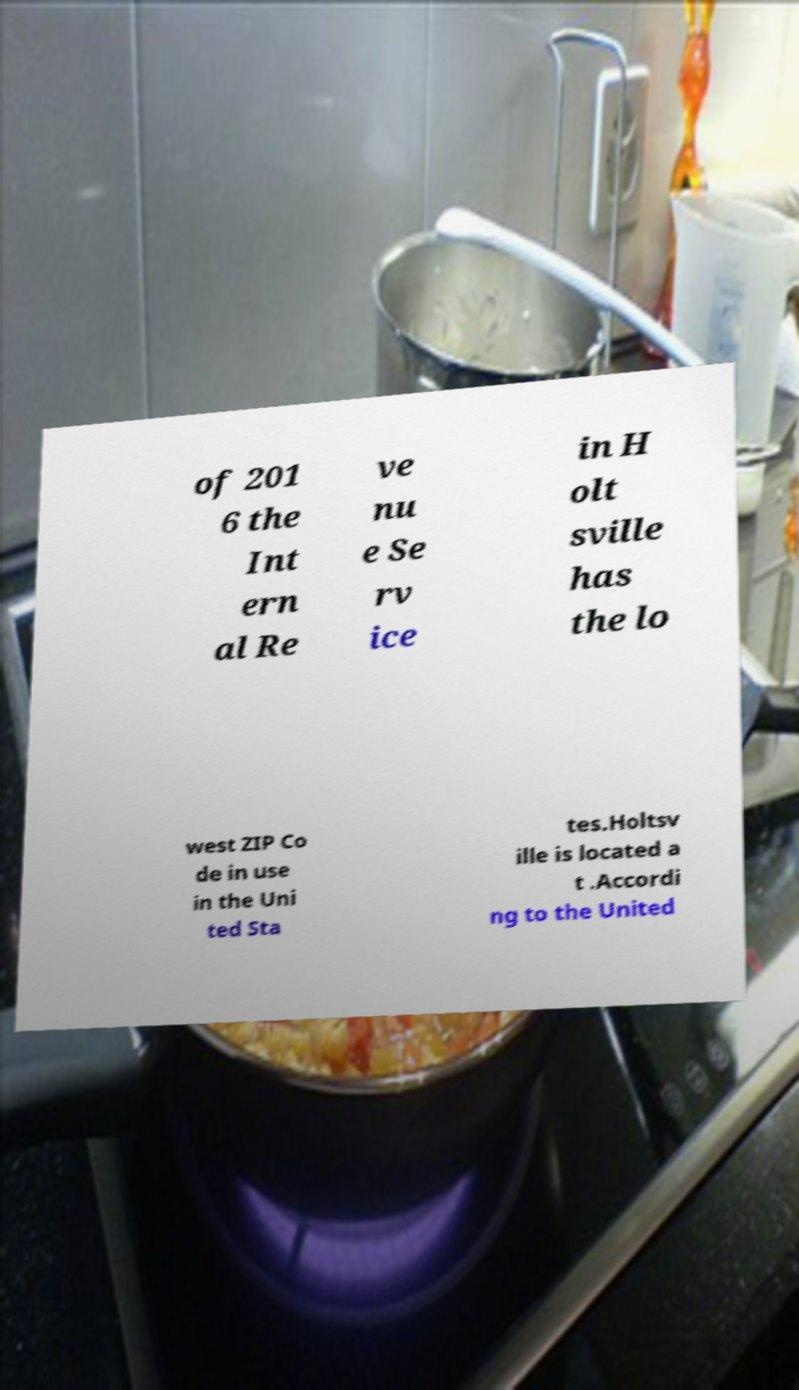Can you accurately transcribe the text from the provided image for me? of 201 6 the Int ern al Re ve nu e Se rv ice in H olt sville has the lo west ZIP Co de in use in the Uni ted Sta tes.Holtsv ille is located a t .Accordi ng to the United 